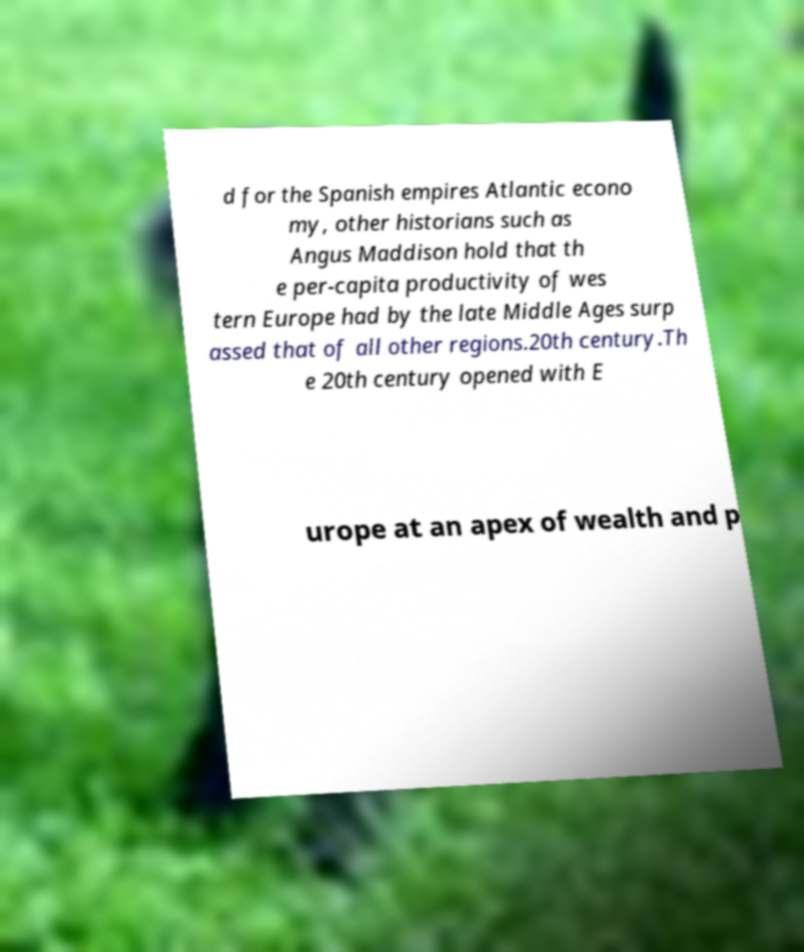There's text embedded in this image that I need extracted. Can you transcribe it verbatim? d for the Spanish empires Atlantic econo my, other historians such as Angus Maddison hold that th e per-capita productivity of wes tern Europe had by the late Middle Ages surp assed that of all other regions.20th century.Th e 20th century opened with E urope at an apex of wealth and p 